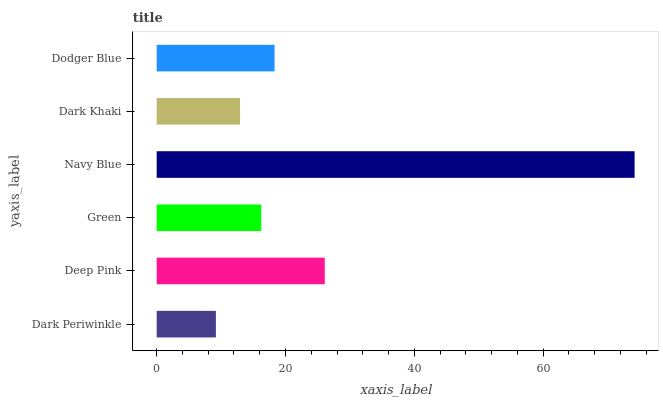Is Dark Periwinkle the minimum?
Answer yes or no. Yes. Is Navy Blue the maximum?
Answer yes or no. Yes. Is Deep Pink the minimum?
Answer yes or no. No. Is Deep Pink the maximum?
Answer yes or no. No. Is Deep Pink greater than Dark Periwinkle?
Answer yes or no. Yes. Is Dark Periwinkle less than Deep Pink?
Answer yes or no. Yes. Is Dark Periwinkle greater than Deep Pink?
Answer yes or no. No. Is Deep Pink less than Dark Periwinkle?
Answer yes or no. No. Is Dodger Blue the high median?
Answer yes or no. Yes. Is Green the low median?
Answer yes or no. Yes. Is Green the high median?
Answer yes or no. No. Is Dark Khaki the low median?
Answer yes or no. No. 